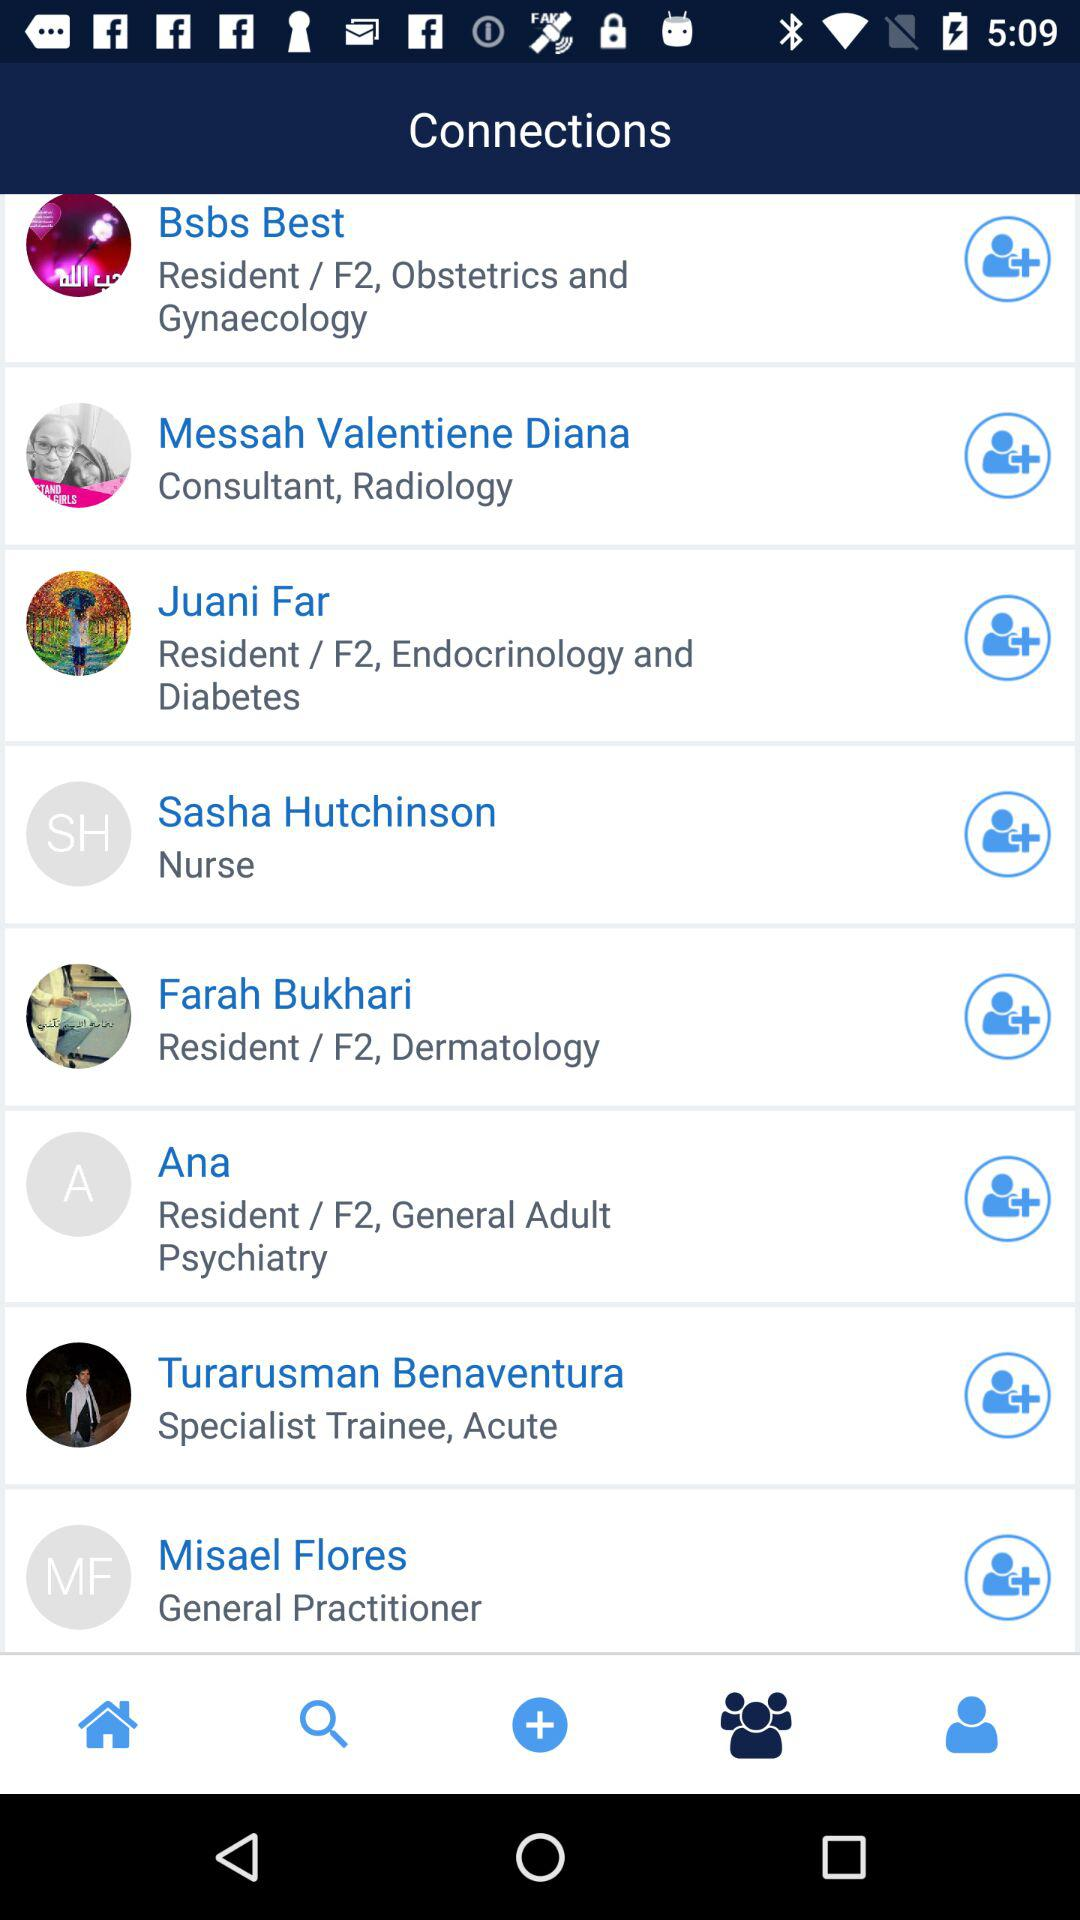What is the profession of Farah Bukhari? The profession of Farah Bukhari is F2, dermatology. 